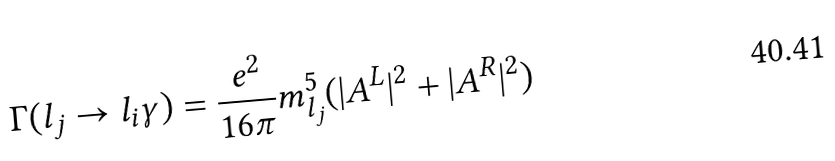Convert formula to latex. <formula><loc_0><loc_0><loc_500><loc_500>\Gamma ( l _ { j } \rightarrow l _ { i } \gamma ) = \frac { e ^ { 2 } } { 1 6 \pi } m ^ { 5 } _ { l _ { j } } ( | A ^ { L } | ^ { 2 } + | A ^ { R } | ^ { 2 } )</formula> 